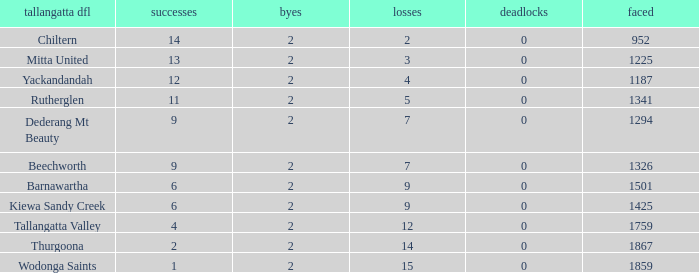What are the losses when there are 9 wins and more than 1326 against? None. 